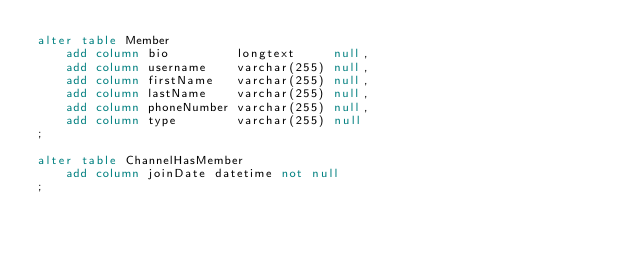Convert code to text. <code><loc_0><loc_0><loc_500><loc_500><_SQL_>alter table Member
    add column bio         longtext     null,
    add column username    varchar(255) null,
    add column firstName   varchar(255) null,
    add column lastName    varchar(255) null,
    add column phoneNumber varchar(255) null,
    add column type        varchar(255) null
;

alter table ChannelHasMember
    add column joinDate datetime not null
;
</code> 